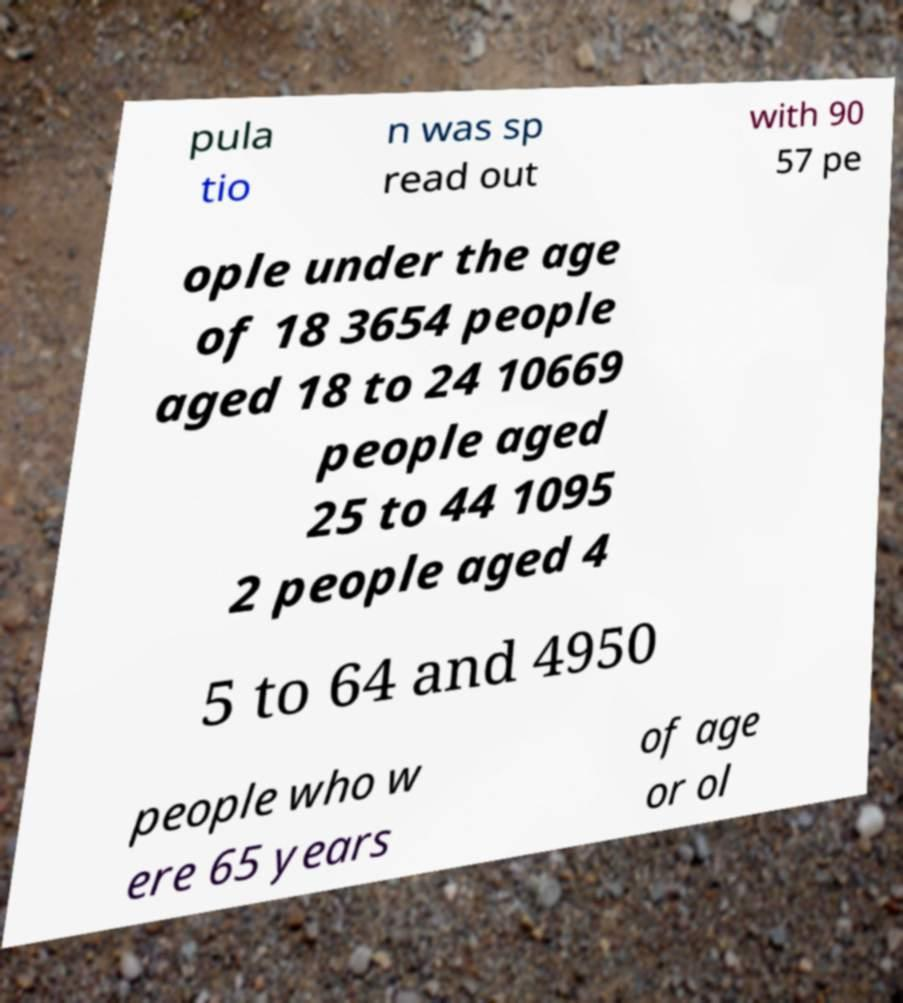Please identify and transcribe the text found in this image. pula tio n was sp read out with 90 57 pe ople under the age of 18 3654 people aged 18 to 24 10669 people aged 25 to 44 1095 2 people aged 4 5 to 64 and 4950 people who w ere 65 years of age or ol 